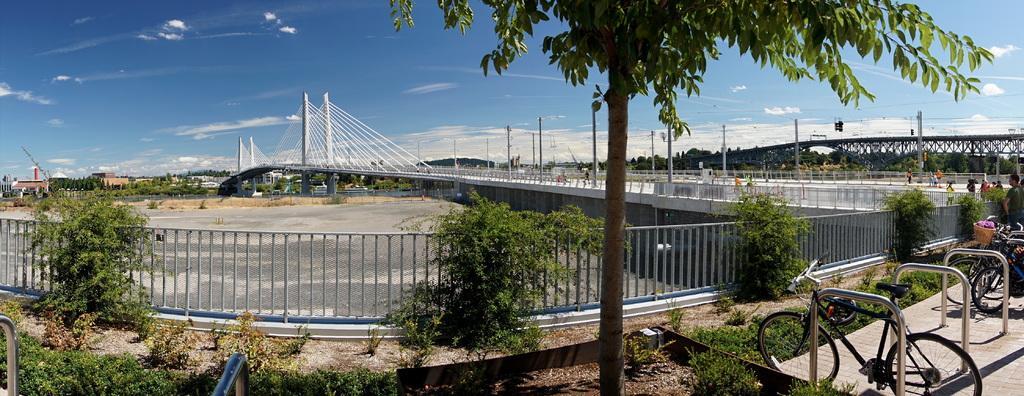Please provide a concise description of this image. In the foreground of this image, on the right, there are bicycles in between poles, plants, railing, two bridges, few poles and the trees. On the left, there are two poles on the bottom and we can also see plants, railing, land, trees, buildings and a tree in the middle. On the top, there is the sky and the cloud. 